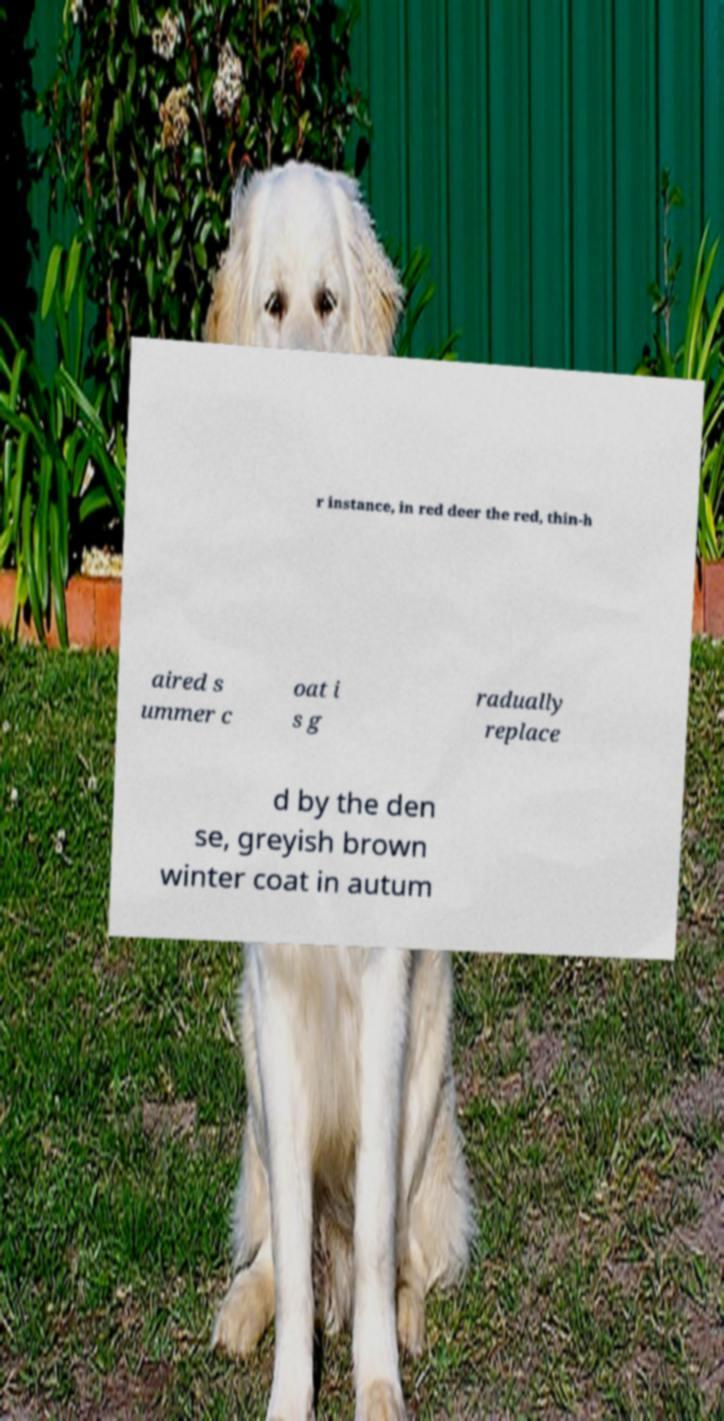Could you assist in decoding the text presented in this image and type it out clearly? r instance, in red deer the red, thin-h aired s ummer c oat i s g radually replace d by the den se, greyish brown winter coat in autum 